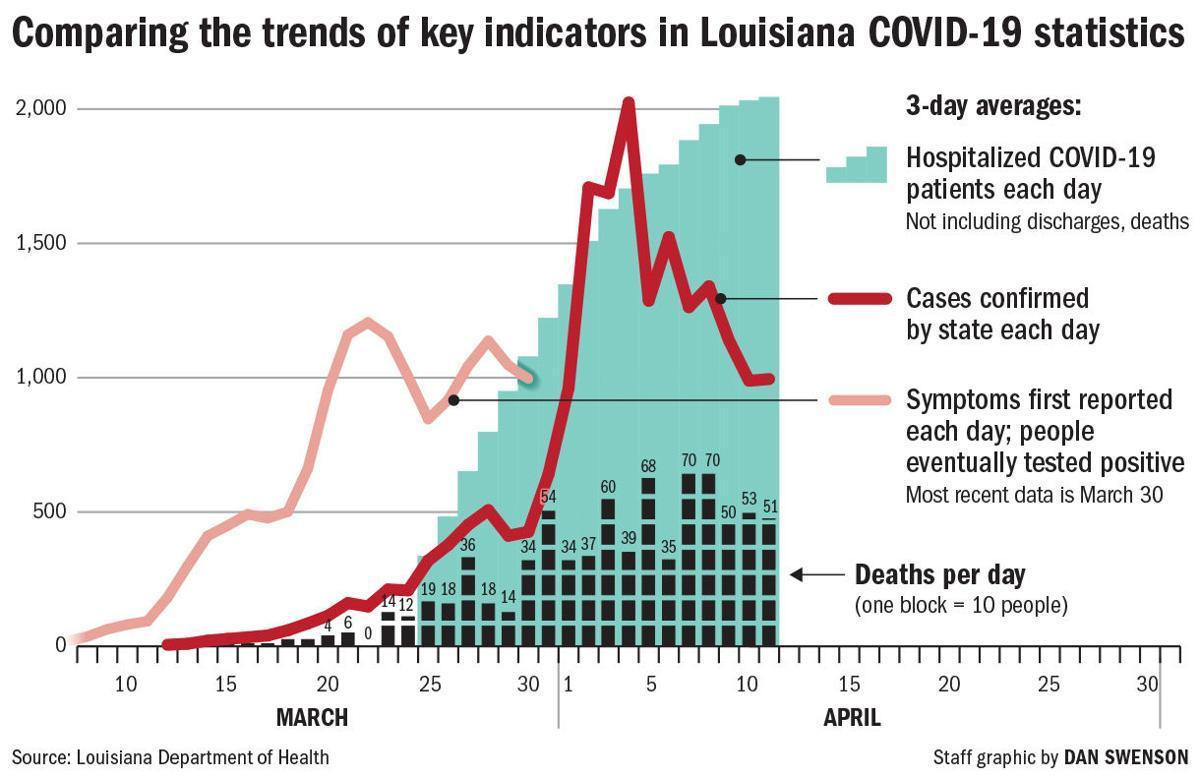How many people equals three blocks?
Answer the question with a short phrase. 30 How many people equals two blocks? 20 Which color is used to represent cases confirmed by the state each day-blue, red, pink? red 